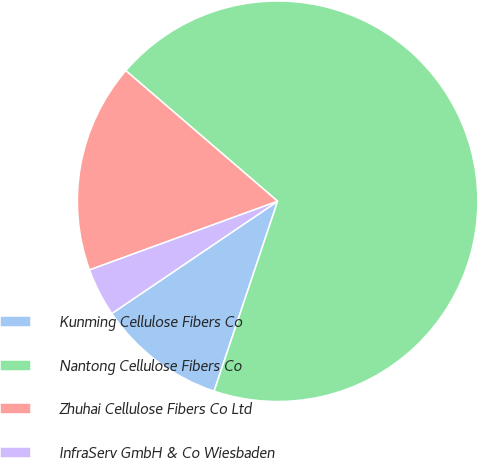<chart> <loc_0><loc_0><loc_500><loc_500><pie_chart><fcel>Kunming Cellulose Fibers Co<fcel>Nantong Cellulose Fibers Co<fcel>Zhuhai Cellulose Fibers Co Ltd<fcel>InfraServ GmbH & Co Wiesbaden<nl><fcel>10.39%<fcel>68.83%<fcel>16.88%<fcel>3.9%<nl></chart> 